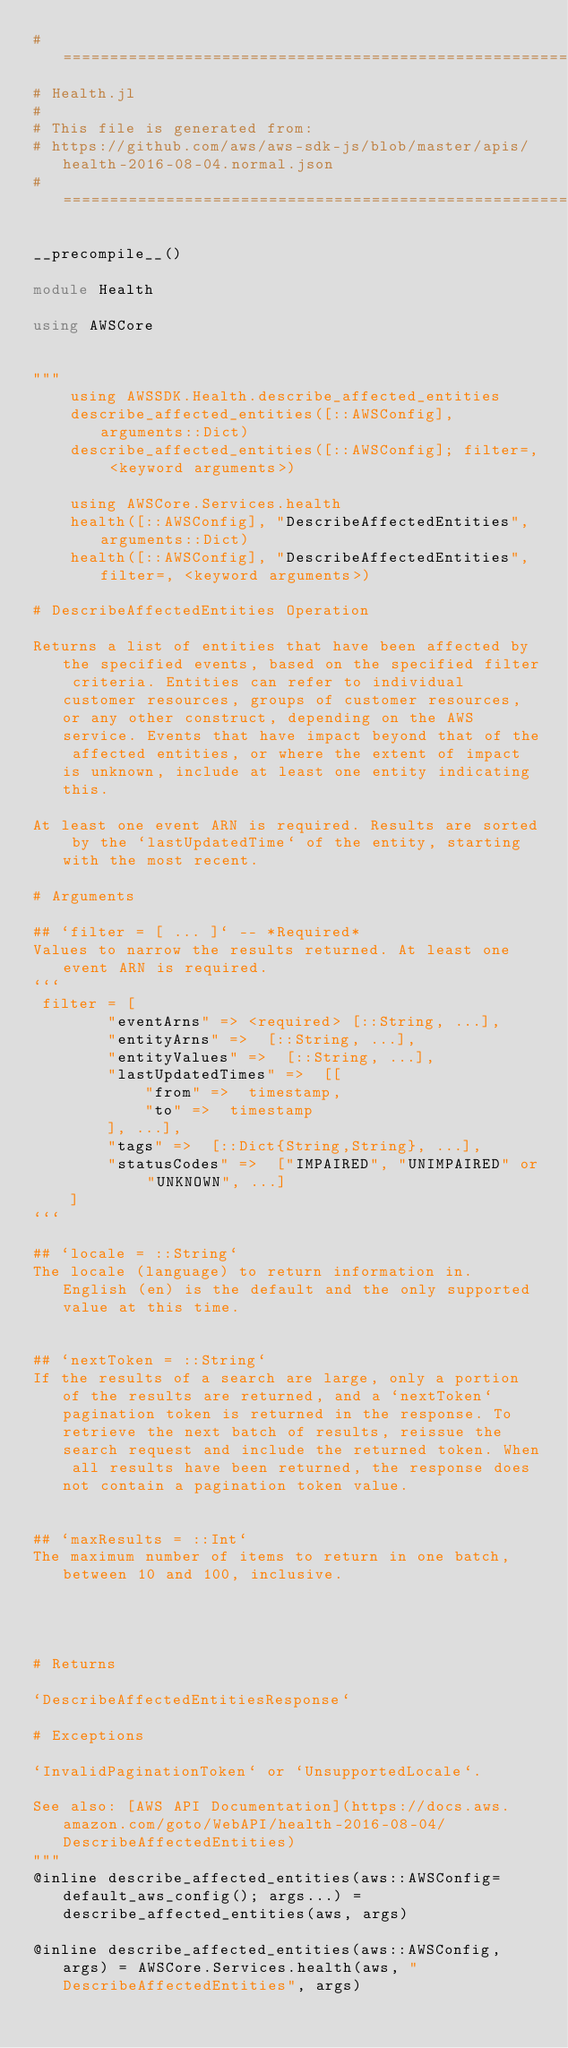<code> <loc_0><loc_0><loc_500><loc_500><_Julia_>#==============================================================================#
# Health.jl
#
# This file is generated from:
# https://github.com/aws/aws-sdk-js/blob/master/apis/health-2016-08-04.normal.json
#==============================================================================#

__precompile__()

module Health

using AWSCore


"""
    using AWSSDK.Health.describe_affected_entities
    describe_affected_entities([::AWSConfig], arguments::Dict)
    describe_affected_entities([::AWSConfig]; filter=, <keyword arguments>)

    using AWSCore.Services.health
    health([::AWSConfig], "DescribeAffectedEntities", arguments::Dict)
    health([::AWSConfig], "DescribeAffectedEntities", filter=, <keyword arguments>)

# DescribeAffectedEntities Operation

Returns a list of entities that have been affected by the specified events, based on the specified filter criteria. Entities can refer to individual customer resources, groups of customer resources, or any other construct, depending on the AWS service. Events that have impact beyond that of the affected entities, or where the extent of impact is unknown, include at least one entity indicating this.

At least one event ARN is required. Results are sorted by the `lastUpdatedTime` of the entity, starting with the most recent.

# Arguments

## `filter = [ ... ]` -- *Required*
Values to narrow the results returned. At least one event ARN is required.
```
 filter = [
        "eventArns" => <required> [::String, ...],
        "entityArns" =>  [::String, ...],
        "entityValues" =>  [::String, ...],
        "lastUpdatedTimes" =>  [[
            "from" =>  timestamp,
            "to" =>  timestamp
        ], ...],
        "tags" =>  [::Dict{String,String}, ...],
        "statusCodes" =>  ["IMPAIRED", "UNIMPAIRED" or "UNKNOWN", ...]
    ]
```

## `locale = ::String`
The locale (language) to return information in. English (en) is the default and the only supported value at this time.


## `nextToken = ::String`
If the results of a search are large, only a portion of the results are returned, and a `nextToken` pagination token is returned in the response. To retrieve the next batch of results, reissue the search request and include the returned token. When all results have been returned, the response does not contain a pagination token value.


## `maxResults = ::Int`
The maximum number of items to return in one batch, between 10 and 100, inclusive.




# Returns

`DescribeAffectedEntitiesResponse`

# Exceptions

`InvalidPaginationToken` or `UnsupportedLocale`.

See also: [AWS API Documentation](https://docs.aws.amazon.com/goto/WebAPI/health-2016-08-04/DescribeAffectedEntities)
"""
@inline describe_affected_entities(aws::AWSConfig=default_aws_config(); args...) = describe_affected_entities(aws, args)

@inline describe_affected_entities(aws::AWSConfig, args) = AWSCore.Services.health(aws, "DescribeAffectedEntities", args)
</code> 